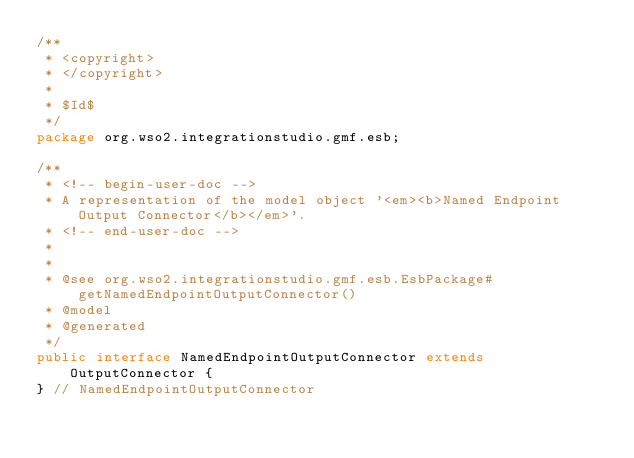<code> <loc_0><loc_0><loc_500><loc_500><_Java_>/**
 * <copyright>
 * </copyright>
 *
 * $Id$
 */
package org.wso2.integrationstudio.gmf.esb;

/**
 * <!-- begin-user-doc -->
 * A representation of the model object '<em><b>Named Endpoint Output Connector</b></em>'.
 * <!-- end-user-doc -->
 *
 *
 * @see org.wso2.integrationstudio.gmf.esb.EsbPackage#getNamedEndpointOutputConnector()
 * @model
 * @generated
 */
public interface NamedEndpointOutputConnector extends OutputConnector {
} // NamedEndpointOutputConnector
</code> 